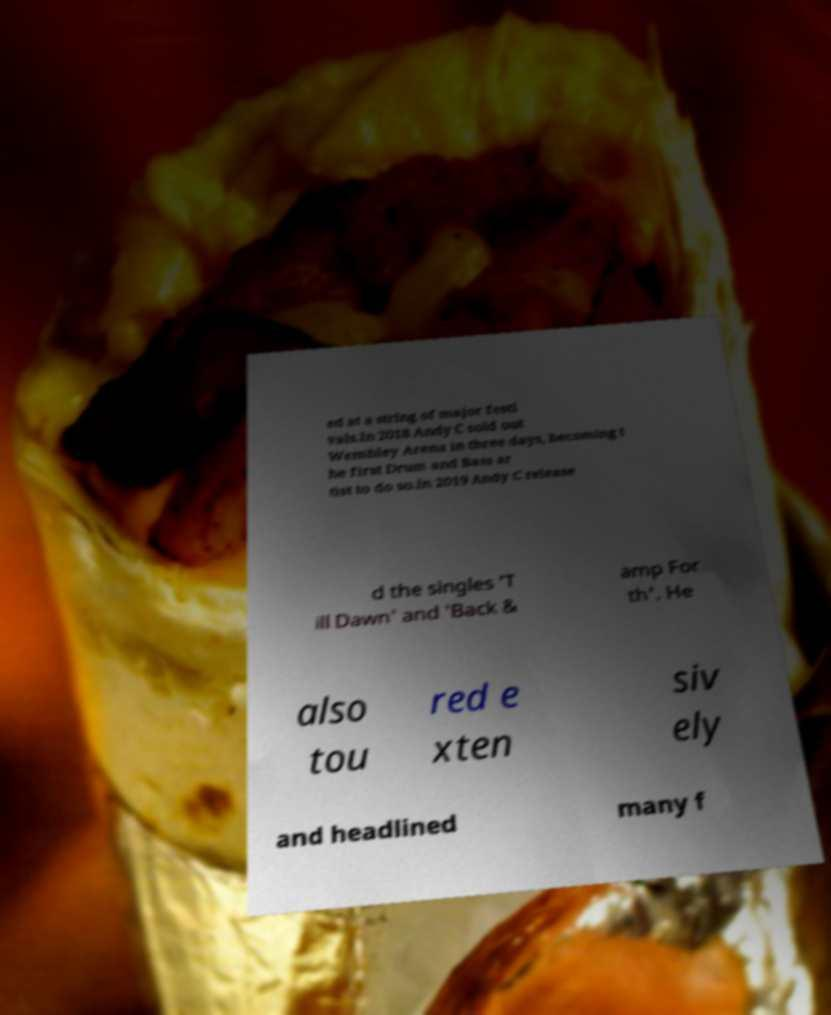Please read and relay the text visible in this image. What does it say? ed at a string of major festi vals.In 2018 Andy C sold out Wembley Arena in three days, becoming t he first Drum and Bass ar tist to do so.In 2019 Andy C release d the singles 'T ill Dawn' and 'Back & amp For th'. He also tou red e xten siv ely and headlined many f 